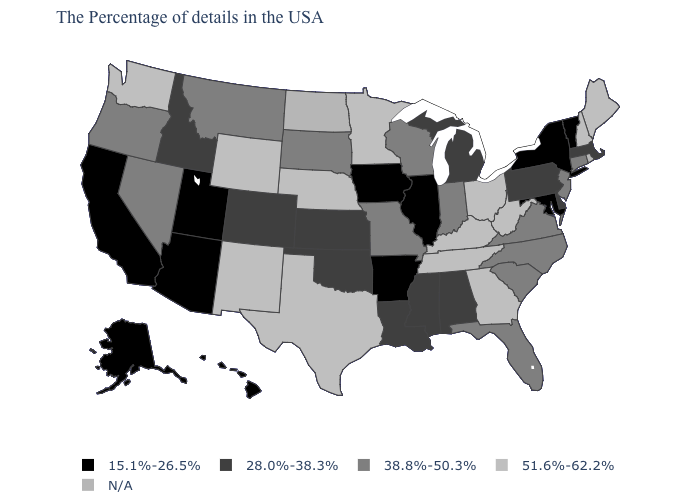What is the value of Oregon?
Write a very short answer. 38.8%-50.3%. What is the value of West Virginia?
Concise answer only. 51.6%-62.2%. What is the value of Idaho?
Concise answer only. 28.0%-38.3%. Which states have the lowest value in the Northeast?
Concise answer only. Vermont, New York. Is the legend a continuous bar?
Write a very short answer. No. What is the value of West Virginia?
Short answer required. 51.6%-62.2%. Name the states that have a value in the range 28.0%-38.3%?
Concise answer only. Massachusetts, Delaware, Pennsylvania, Michigan, Alabama, Mississippi, Louisiana, Kansas, Oklahoma, Colorado, Idaho. Name the states that have a value in the range 38.8%-50.3%?
Write a very short answer. Connecticut, New Jersey, Virginia, North Carolina, South Carolina, Florida, Indiana, Wisconsin, Missouri, South Dakota, Montana, Nevada, Oregon. What is the value of South Carolina?
Concise answer only. 38.8%-50.3%. Which states hav the highest value in the West?
Answer briefly. Wyoming, New Mexico, Washington. Which states hav the highest value in the South?
Answer briefly. West Virginia, Georgia, Kentucky, Tennessee, Texas. Among the states that border New Jersey , does New York have the highest value?
Answer briefly. No. 